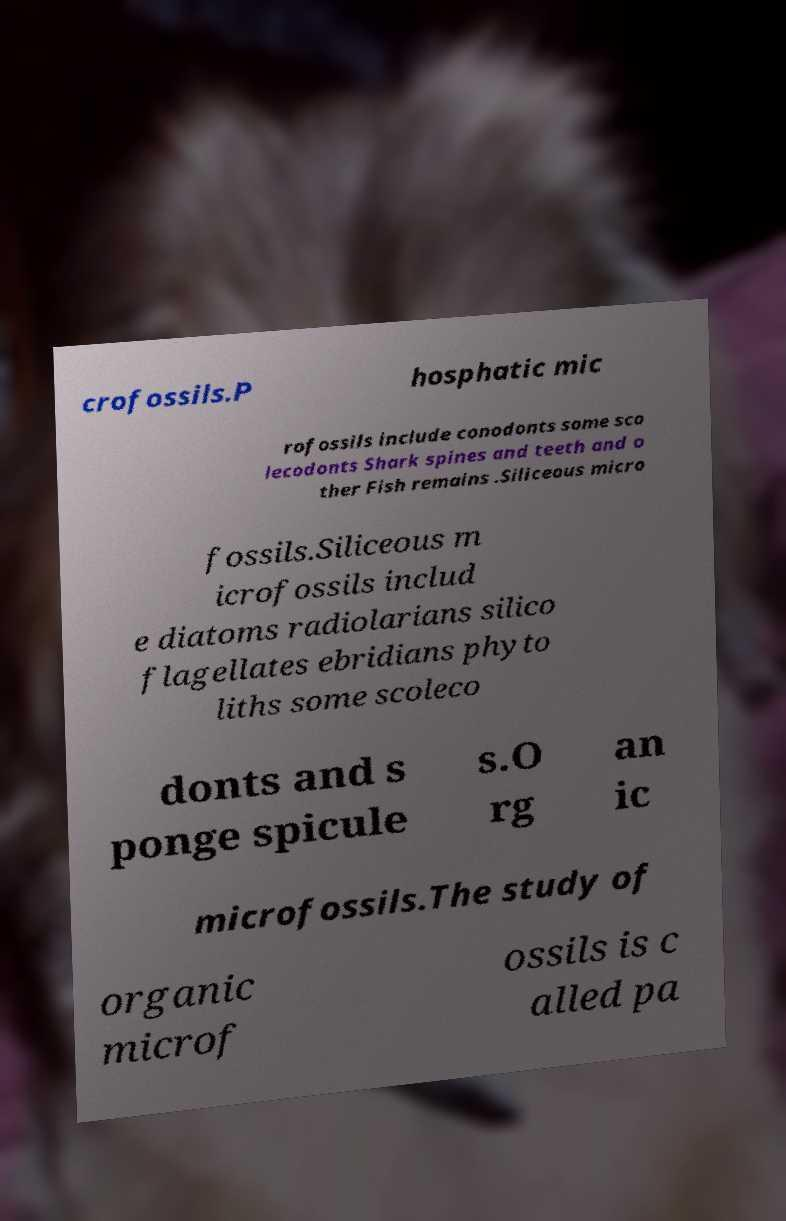Please read and relay the text visible in this image. What does it say? crofossils.P hosphatic mic rofossils include conodonts some sco lecodonts Shark spines and teeth and o ther Fish remains .Siliceous micro fossils.Siliceous m icrofossils includ e diatoms radiolarians silico flagellates ebridians phyto liths some scoleco donts and s ponge spicule s.O rg an ic microfossils.The study of organic microf ossils is c alled pa 